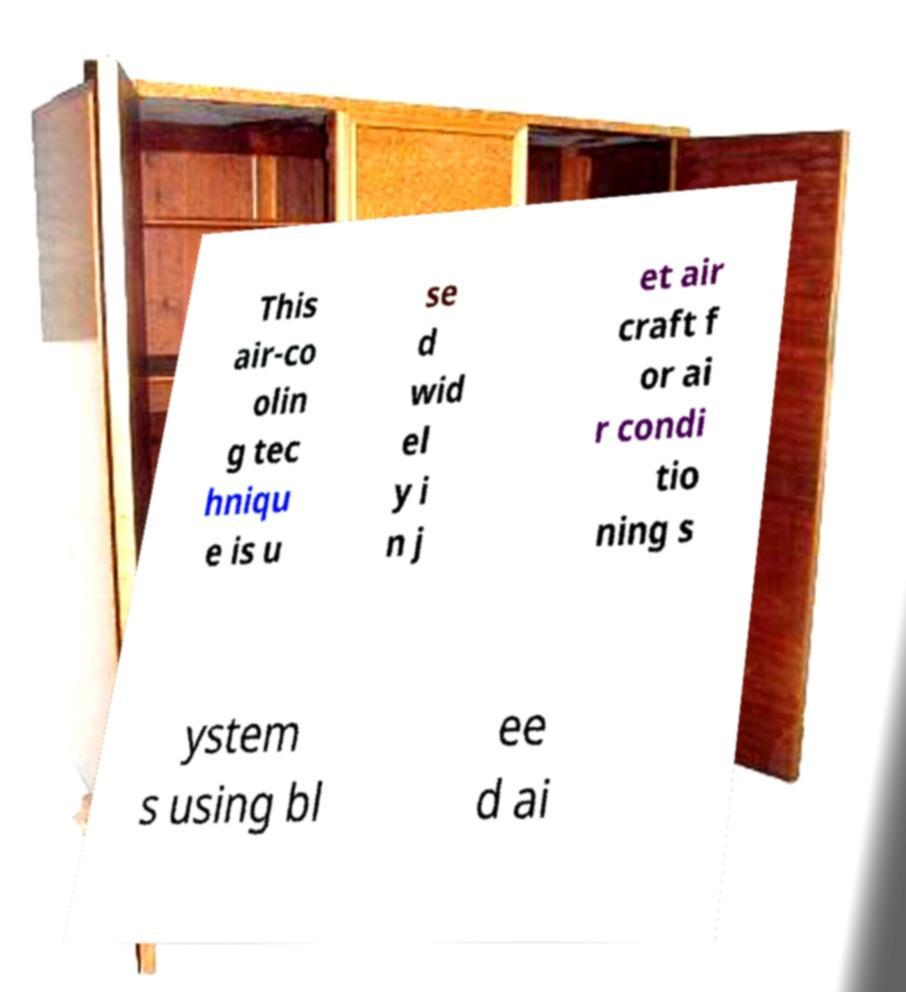Can you accurately transcribe the text from the provided image for me? This air-co olin g tec hniqu e is u se d wid el y i n j et air craft f or ai r condi tio ning s ystem s using bl ee d ai 